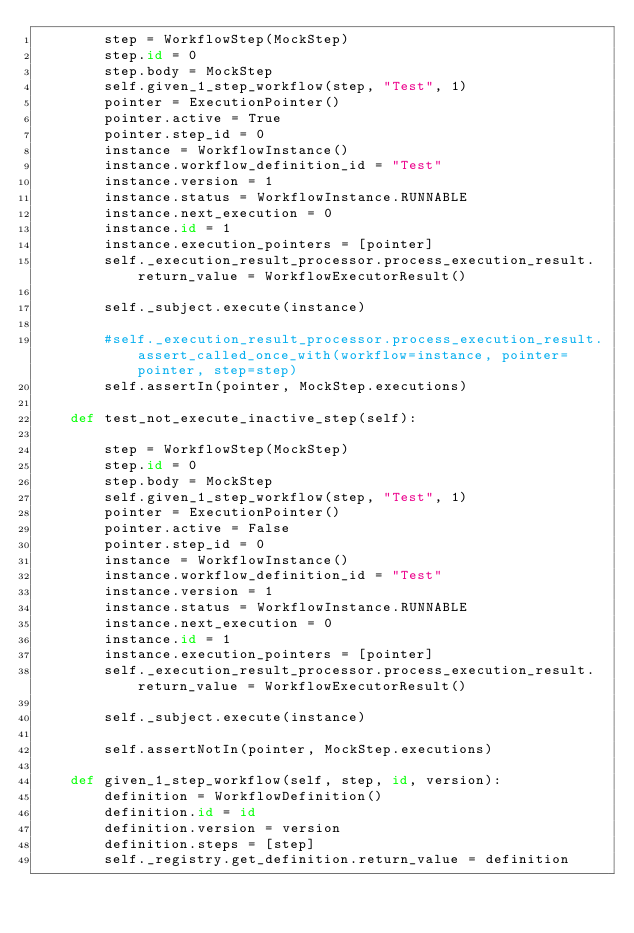<code> <loc_0><loc_0><loc_500><loc_500><_Python_>        step = WorkflowStep(MockStep)
        step.id = 0
        step.body = MockStep
        self.given_1_step_workflow(step, "Test", 1)
        pointer = ExecutionPointer()
        pointer.active = True
        pointer.step_id = 0
        instance = WorkflowInstance()
        instance.workflow_definition_id = "Test"
        instance.version = 1
        instance.status = WorkflowInstance.RUNNABLE
        instance.next_execution = 0
        instance.id = 1
        instance.execution_pointers = [pointer]
        self._execution_result_processor.process_execution_result.return_value = WorkflowExecutorResult()

        self._subject.execute(instance)

        #self._execution_result_processor.process_execution_result.assert_called_once_with(workflow=instance, pointer=pointer, step=step)
        self.assertIn(pointer, MockStep.executions)

    def test_not_execute_inactive_step(self):

        step = WorkflowStep(MockStep)
        step.id = 0
        step.body = MockStep
        self.given_1_step_workflow(step, "Test", 1)
        pointer = ExecutionPointer()
        pointer.active = False
        pointer.step_id = 0
        instance = WorkflowInstance()
        instance.workflow_definition_id = "Test"
        instance.version = 1
        instance.status = WorkflowInstance.RUNNABLE
        instance.next_execution = 0
        instance.id = 1
        instance.execution_pointers = [pointer]
        self._execution_result_processor.process_execution_result.return_value = WorkflowExecutorResult()

        self._subject.execute(instance)

        self.assertNotIn(pointer, MockStep.executions)

    def given_1_step_workflow(self, step, id, version):
        definition = WorkflowDefinition()
        definition.id = id
        definition.version = version
        definition.steps = [step]
        self._registry.get_definition.return_value = definition
</code> 